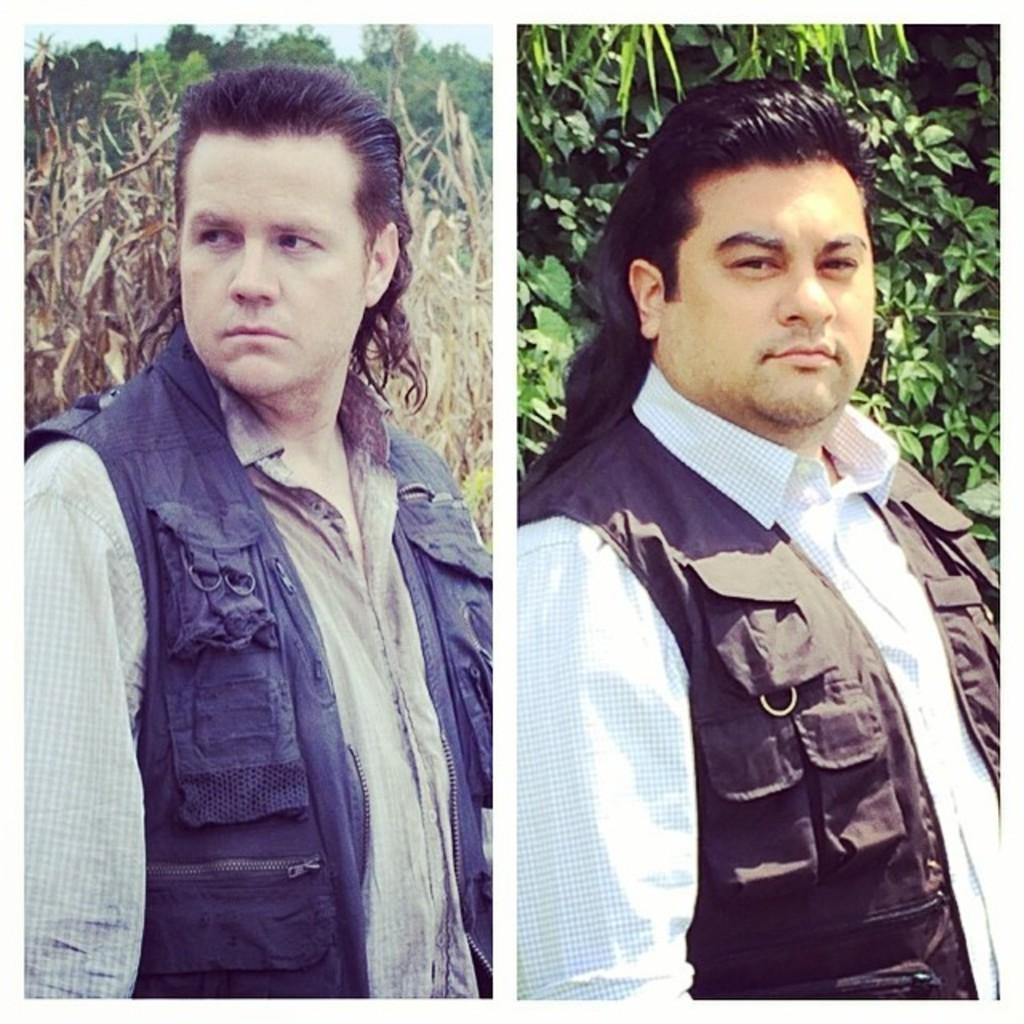What is the composition of the image? The image is a collage of two images. Are the two images in the collage similar or different? Both images are the same. Can you describe the person in the image? There is a man standing in the image. What can be seen in the background of the image? Trees and plants are visible in the background of the image. How long does the girl take to walk across the image? There is no girl present in the image, so it is not possible to determine how long it would take for her to walk across the image. 